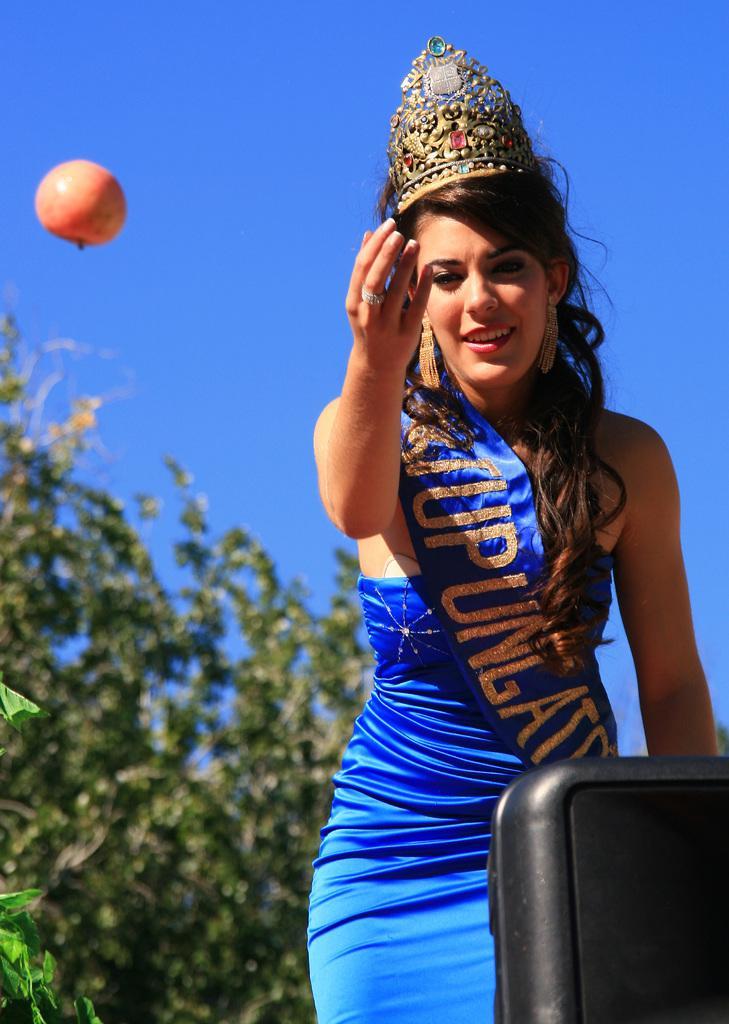In one or two sentences, can you explain what this image depicts? In this image we can see a woman, she is wearing blue color dress and crown on her head. Behind her tree is there and in air one fruit is present. The sky is in blue color. 